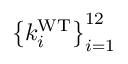<formula> <loc_0><loc_0><loc_500><loc_500>\left \{ k _ { i } ^ { W T } \right \} _ { i = 1 } ^ { 1 2 }</formula> 